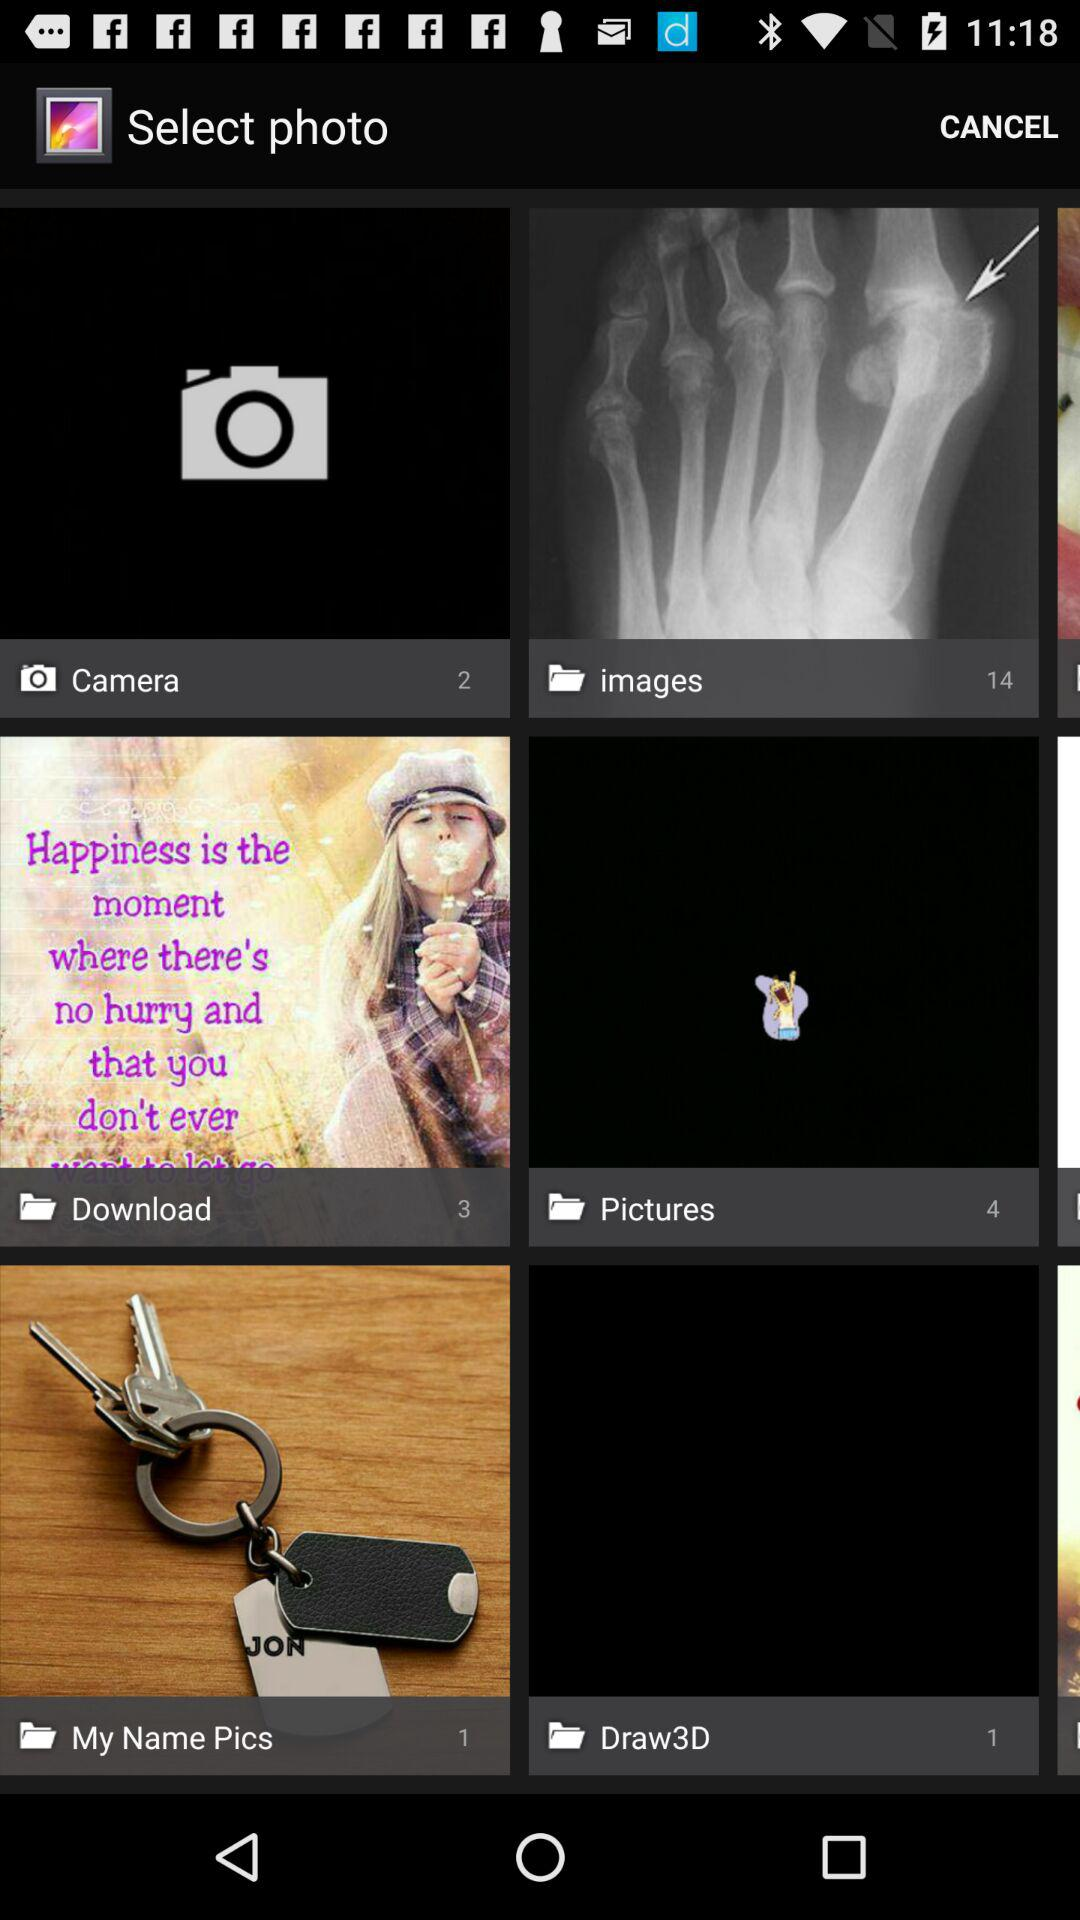What is the number of pictures in the "images" folder? The number of pictures in the "images" folder is 14. 